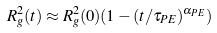Convert formula to latex. <formula><loc_0><loc_0><loc_500><loc_500>R _ { g } ^ { 2 } ( t ) \approx R _ { g } ^ { 2 } ( 0 ) ( 1 - ( t / \tau _ { P E } ) ^ { \alpha _ { P E } } )</formula> 